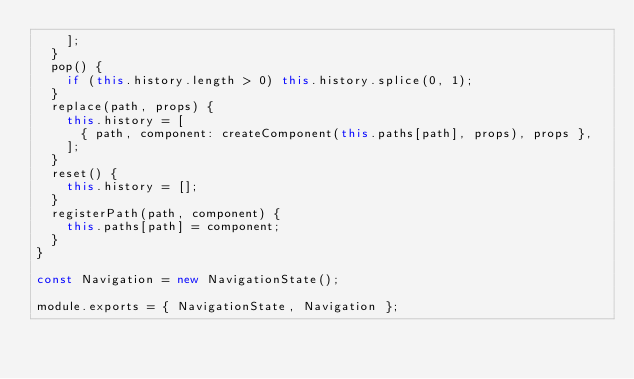Convert code to text. <code><loc_0><loc_0><loc_500><loc_500><_JavaScript_>    ];
  }
  pop() {
    if (this.history.length > 0) this.history.splice(0, 1);
  }
  replace(path, props) {
    this.history = [
      { path, component: createComponent(this.paths[path], props), props },
    ];
  }
  reset() {
    this.history = [];
  }
  registerPath(path, component) {
    this.paths[path] = component;
  }
}

const Navigation = new NavigationState();

module.exports = { NavigationState, Navigation };</code> 